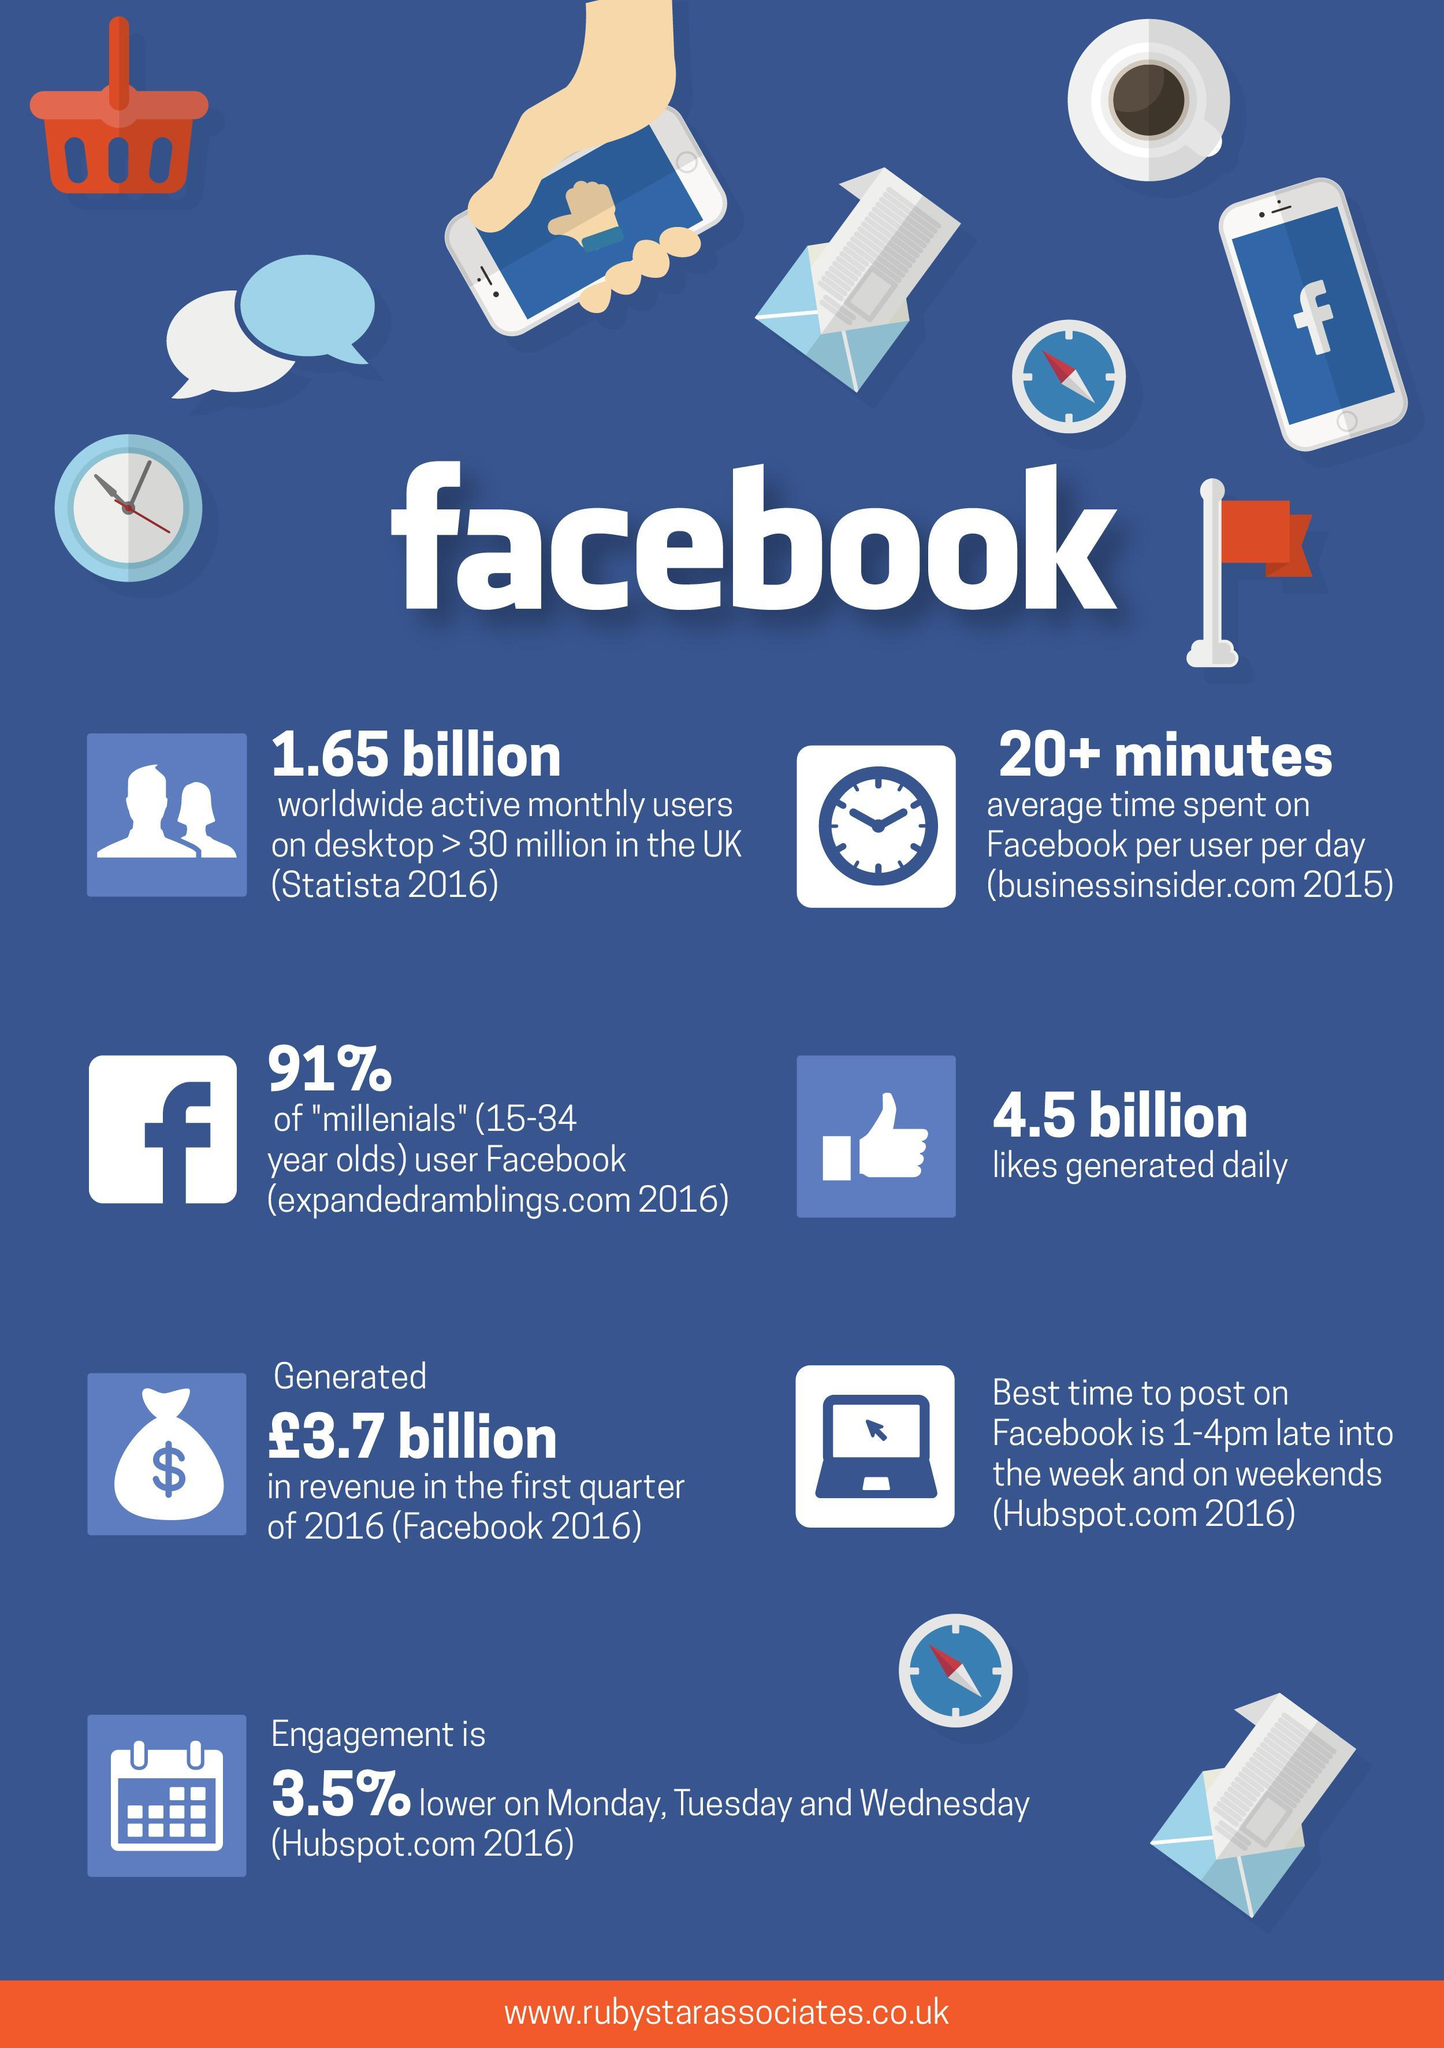When is the engagement not high during the week?
Answer the question with a short phrase. Monday, Tuesday, Wednesday What percent of Facebook users are people other than millenials? 9% 